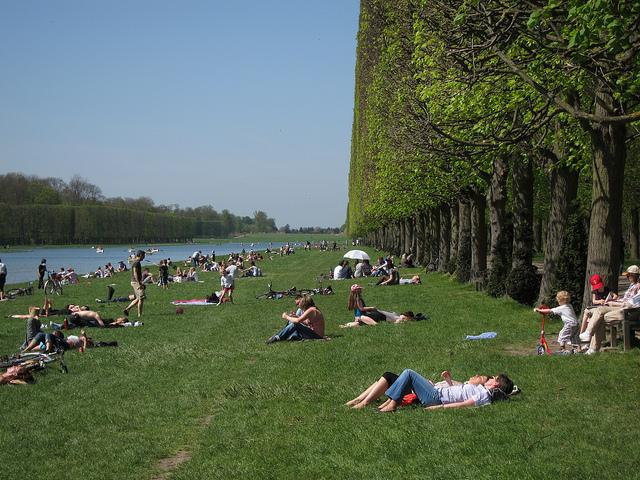Why are these people laying here? Please explain your reasoning. good weather. The weather is good. 